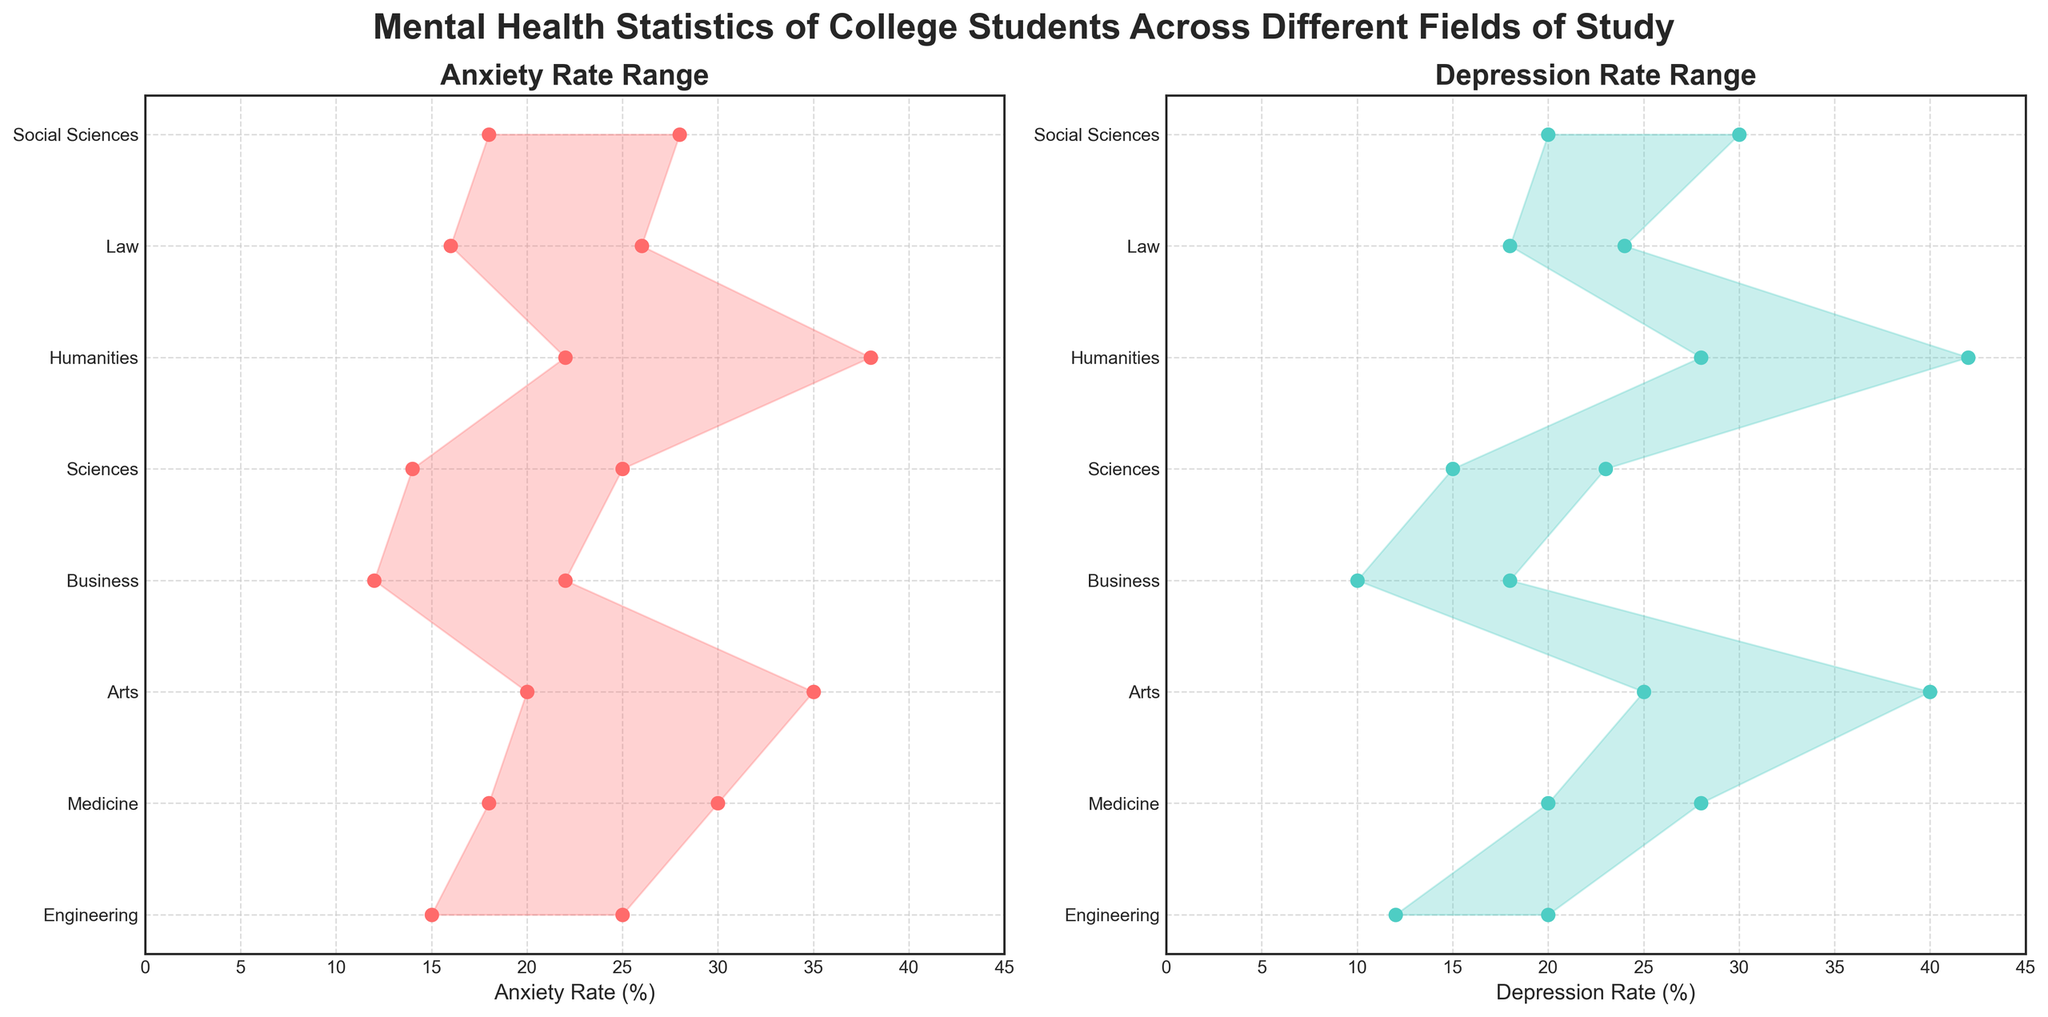What's the title of the figure? The title of the figure is displayed at the top of the chart. It reads "Mental Health Statistics of College Students Across Different Fields of Study".
Answer: "Mental Health Statistics of College Students Across Different Fields of Study" Which field has the highest maximum anxiety rate? Look at the "Anxiety Rate Range" plot on the left, and identify the highest maximum point on the x-axis. It is for the "Humanities" field with a maximum anxiety rate of 38%.
Answer: Humanities What is the range of depression rates for Arts students? In the "Depression Rate Range" plot on the right, find the "Arts" field and note the minimum and maximum values on the x-axis. The range is from 25% to 40%.
Answer: 25%-40% How does the minimum anxiety rate of Medicine compare with that of Social Sciences? Identify the minimum anxiety rates for both Medicine and Social Sciences in the "Anxiety Rate Range" plot. Medicine has a minimum rate of 18%, while Social Sciences also shows 18%. Both rates are equal.
Answer: Equal Which fields show a minimum depression rate of 20%? Refer to the "Depression Rate Range" plot and locate the fields that align with a minimum depression rate of 20%. Medicine and Social Sciences both show this rate.
Answer: Medicine, Social Sciences What is the average maximum anxiety rate across all fields of study? Add up the maximum anxiety rates for all fields: (25 + 30 + 35 + 22 + 25 + 38 + 26 + 28) = 229. There are 8 fields, so the average is 229 / 8 = 28.625%
Answer: 28.625% Which field has the smallest depression rate range? The depression rate range is the difference between the maximum and minimum values of depression rates for each field. For each field, calculate the differences, and find the smallest:
Engineering (20 - 12 = 8), Medicine (28 - 20 = 8), Arts (40 - 25 = 15), Business (18 - 10 = 8), Sciences (23 - 15 = 8), Humanities (42 - 28 = 14), Law (24 - 18 = 6), Social Sciences (30 - 20 = 10). Law has the smallest range, which is 6%.
Answer: Law What is the difference between the maximum depression rate of Humanities and the maximum depression rate of Business? The maximum depression rate for Humanities is 42%, and for Business, it is 18%. The difference is 42 - 18 = 24%.
Answer: 24% Is the range between the minimum and maximum anxiety rates in Engineering greater than that in Law? For Engineering, the anxiety rate range is 25 - 15 = 10%. For Law, it is 26 - 16 = 10%. The ranges are equal.
Answer: No, they are equal In which field do students exhibit both higher maximum anxiety and depression rates compared to Law? From the "Anxiety Rate Range" and "Depression Rate Range" plots, identify fields where the maximum rates for both anxiety and depression are higher than those of Law. Humanities and Arts both have higher maximum rates for anxiety (38%, 35%) and depression (42%, 40%) compared to Law (anxiety: 26%, depression: 24%).
Answer: Humanities, Arts 